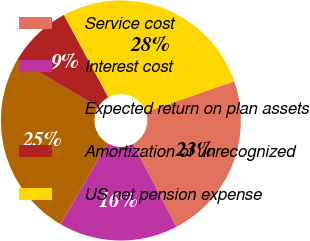Convert chart. <chart><loc_0><loc_0><loc_500><loc_500><pie_chart><fcel>Service cost<fcel>Interest cost<fcel>Expected return on plan assets<fcel>Amortization of unrecognized<fcel>US net pension expense<nl><fcel>22.65%<fcel>16.04%<fcel>25.11%<fcel>8.62%<fcel>27.57%<nl></chart> 